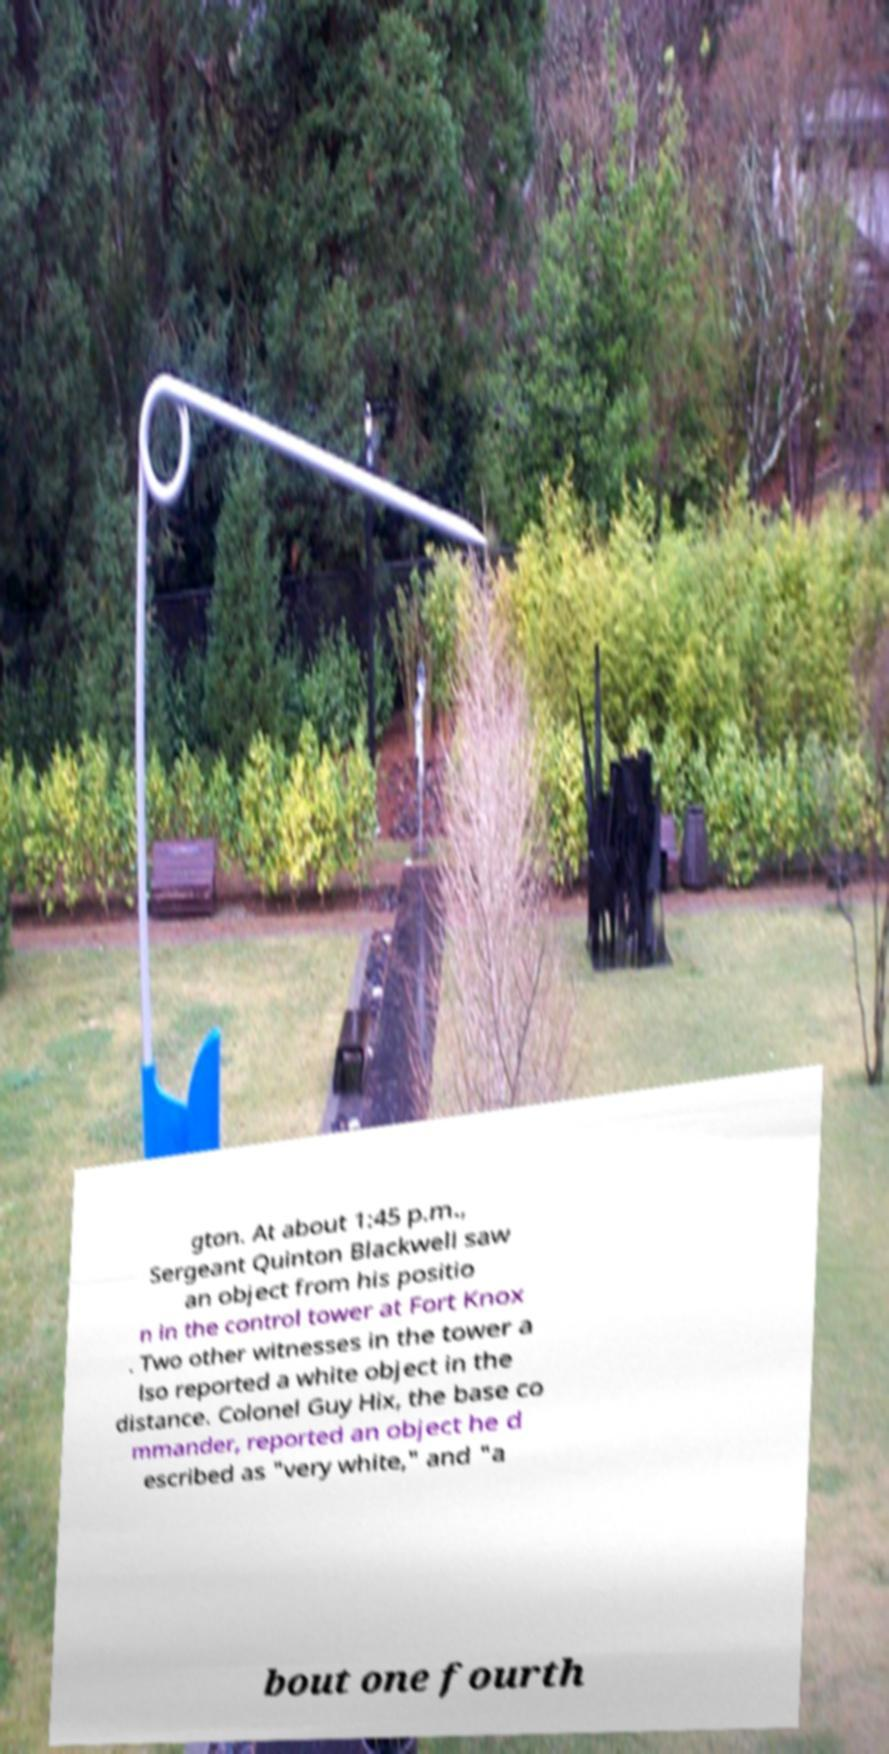What messages or text are displayed in this image? I need them in a readable, typed format. gton. At about 1:45 p.m., Sergeant Quinton Blackwell saw an object from his positio n in the control tower at Fort Knox . Two other witnesses in the tower a lso reported a white object in the distance. Colonel Guy Hix, the base co mmander, reported an object he d escribed as "very white," and "a bout one fourth 